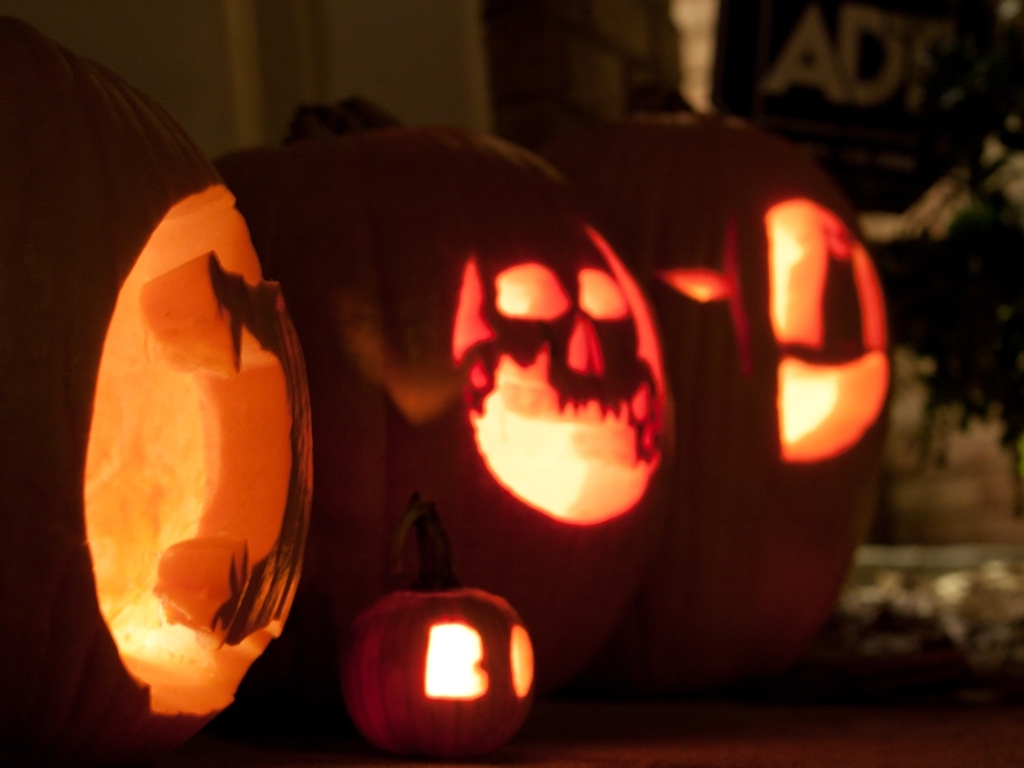Break down the quality aspects of the image and judge it from your analysis.
 This image is overall underexposed and lacks proper exposure. The focus is blurry and the texture of the pumpkin is also not clear. The bright areas are very bright, while the dark areas are very dark. Therefore, the quality of this image is poor. 